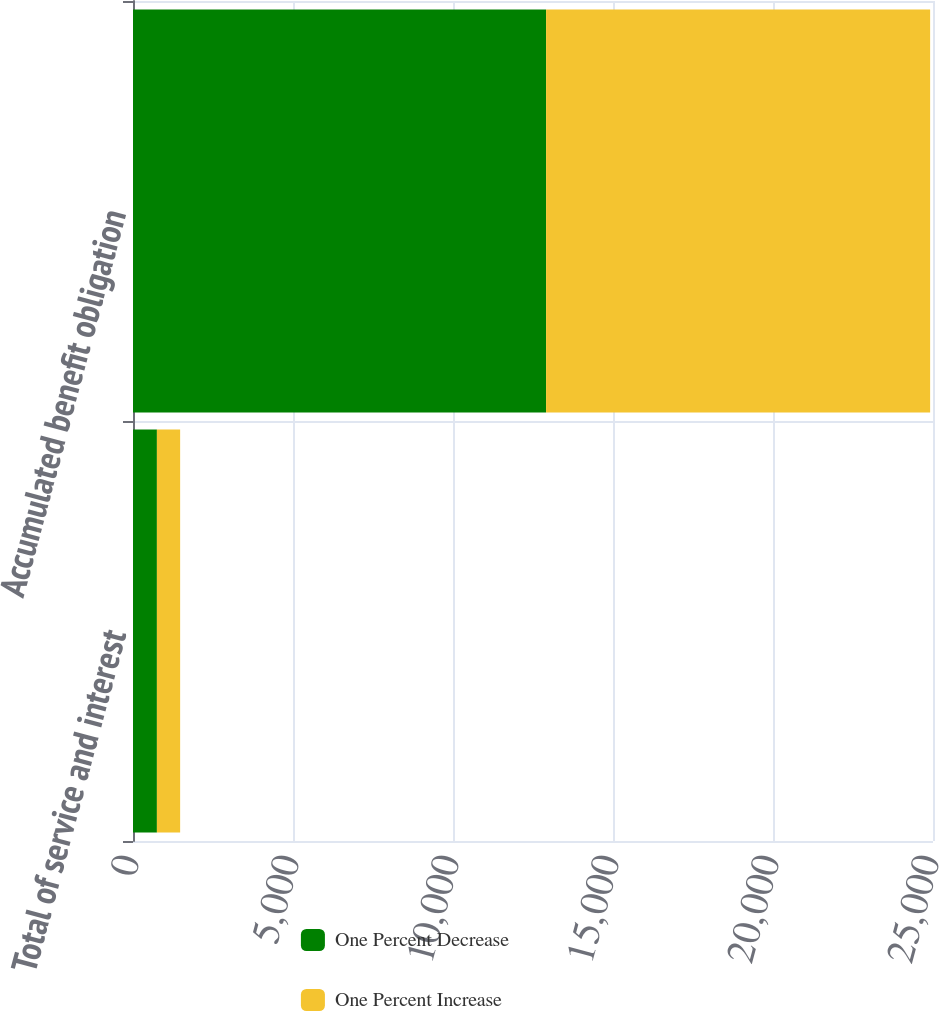<chart> <loc_0><loc_0><loc_500><loc_500><stacked_bar_chart><ecel><fcel>Total of service and interest<fcel>Accumulated benefit obligation<nl><fcel>One Percent Decrease<fcel>747<fcel>12909<nl><fcel>One Percent Increase<fcel>726<fcel>12001<nl></chart> 